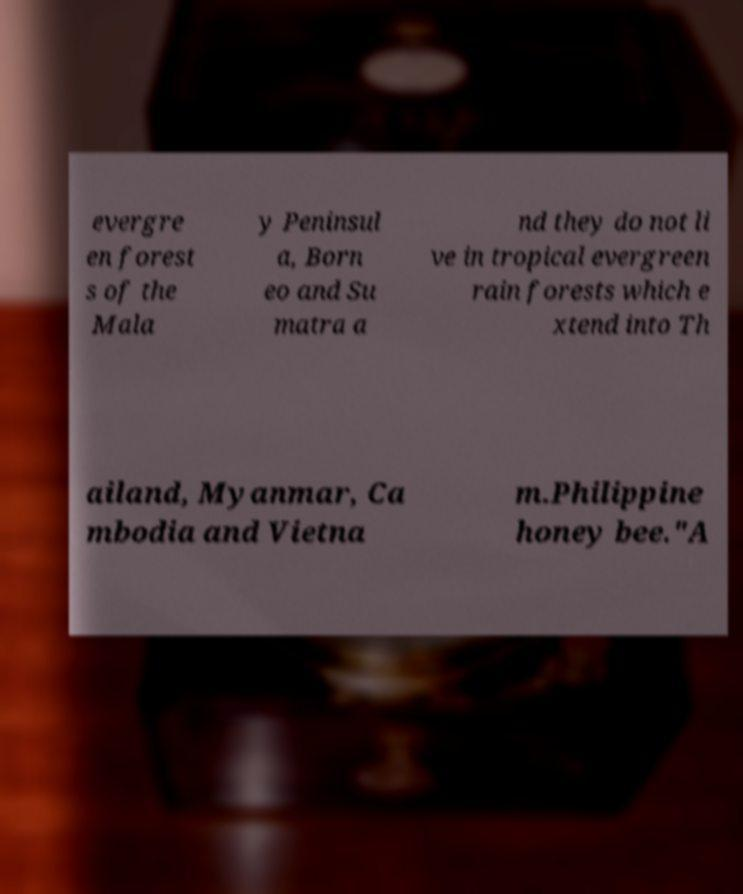Can you accurately transcribe the text from the provided image for me? evergre en forest s of the Mala y Peninsul a, Born eo and Su matra a nd they do not li ve in tropical evergreen rain forests which e xtend into Th ailand, Myanmar, Ca mbodia and Vietna m.Philippine honey bee."A 